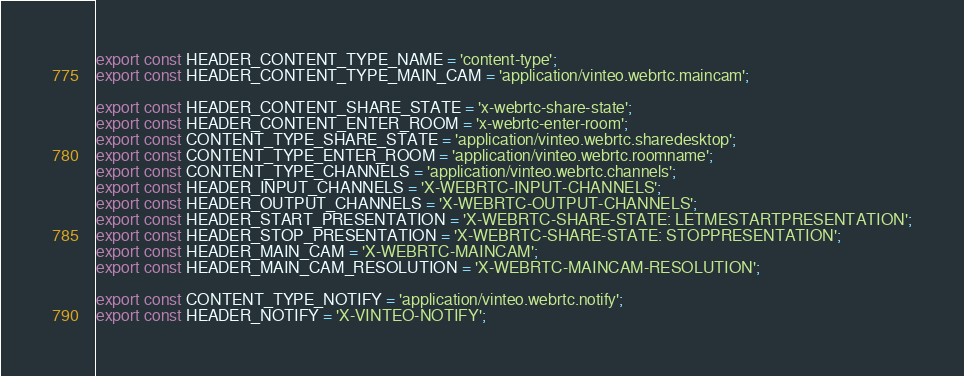<code> <loc_0><loc_0><loc_500><loc_500><_TypeScript_>export const HEADER_CONTENT_TYPE_NAME = 'content-type';
export const HEADER_CONTENT_TYPE_MAIN_CAM = 'application/vinteo.webrtc.maincam';

export const HEADER_CONTENT_SHARE_STATE = 'x-webrtc-share-state';
export const HEADER_CONTENT_ENTER_ROOM = 'x-webrtc-enter-room';
export const CONTENT_TYPE_SHARE_STATE = 'application/vinteo.webrtc.sharedesktop';
export const CONTENT_TYPE_ENTER_ROOM = 'application/vinteo.webrtc.roomname';
export const CONTENT_TYPE_CHANNELS = 'application/vinteo.webrtc.channels';
export const HEADER_INPUT_CHANNELS = 'X-WEBRTC-INPUT-CHANNELS';
export const HEADER_OUTPUT_CHANNELS = 'X-WEBRTC-OUTPUT-CHANNELS';
export const HEADER_START_PRESENTATION = 'X-WEBRTC-SHARE-STATE: LETMESTARTPRESENTATION';
export const HEADER_STOP_PRESENTATION = 'X-WEBRTC-SHARE-STATE: STOPPRESENTATION';
export const HEADER_MAIN_CAM = 'X-WEBRTC-MAINCAM';
export const HEADER_MAIN_CAM_RESOLUTION = 'X-WEBRTC-MAINCAM-RESOLUTION';

export const CONTENT_TYPE_NOTIFY = 'application/vinteo.webrtc.notify';
export const HEADER_NOTIFY = 'X-VINTEO-NOTIFY';
</code> 